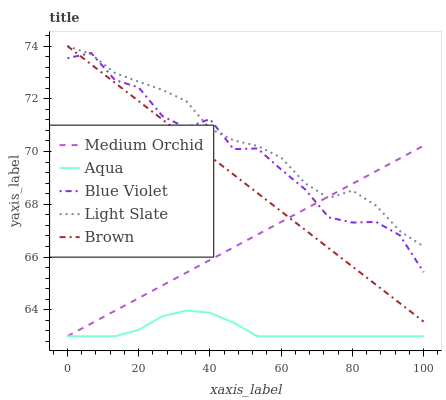Does Aqua have the minimum area under the curve?
Answer yes or no. Yes. Does Light Slate have the maximum area under the curve?
Answer yes or no. Yes. Does Brown have the minimum area under the curve?
Answer yes or no. No. Does Brown have the maximum area under the curve?
Answer yes or no. No. Is Medium Orchid the smoothest?
Answer yes or no. Yes. Is Blue Violet the roughest?
Answer yes or no. Yes. Is Brown the smoothest?
Answer yes or no. No. Is Brown the roughest?
Answer yes or no. No. Does Medium Orchid have the lowest value?
Answer yes or no. Yes. Does Brown have the lowest value?
Answer yes or no. No. Does Brown have the highest value?
Answer yes or no. Yes. Does Medium Orchid have the highest value?
Answer yes or no. No. Is Aqua less than Blue Violet?
Answer yes or no. Yes. Is Light Slate greater than Aqua?
Answer yes or no. Yes. Does Medium Orchid intersect Blue Violet?
Answer yes or no. Yes. Is Medium Orchid less than Blue Violet?
Answer yes or no. No. Is Medium Orchid greater than Blue Violet?
Answer yes or no. No. Does Aqua intersect Blue Violet?
Answer yes or no. No. 